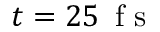<formula> <loc_0><loc_0><loc_500><loc_500>t = 2 5 \, f s</formula> 